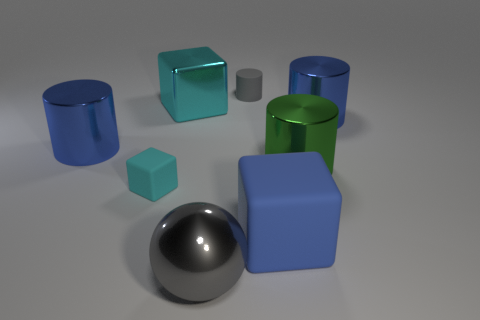Subtract all red cylinders. Subtract all red spheres. How many cylinders are left? 4 Add 1 big green cylinders. How many objects exist? 9 Subtract all balls. How many objects are left? 7 Add 1 cyan cubes. How many cyan cubes are left? 3 Add 3 large cyan metal objects. How many large cyan metal objects exist? 4 Subtract 0 red blocks. How many objects are left? 8 Subtract all metallic cubes. Subtract all big gray shiny spheres. How many objects are left? 6 